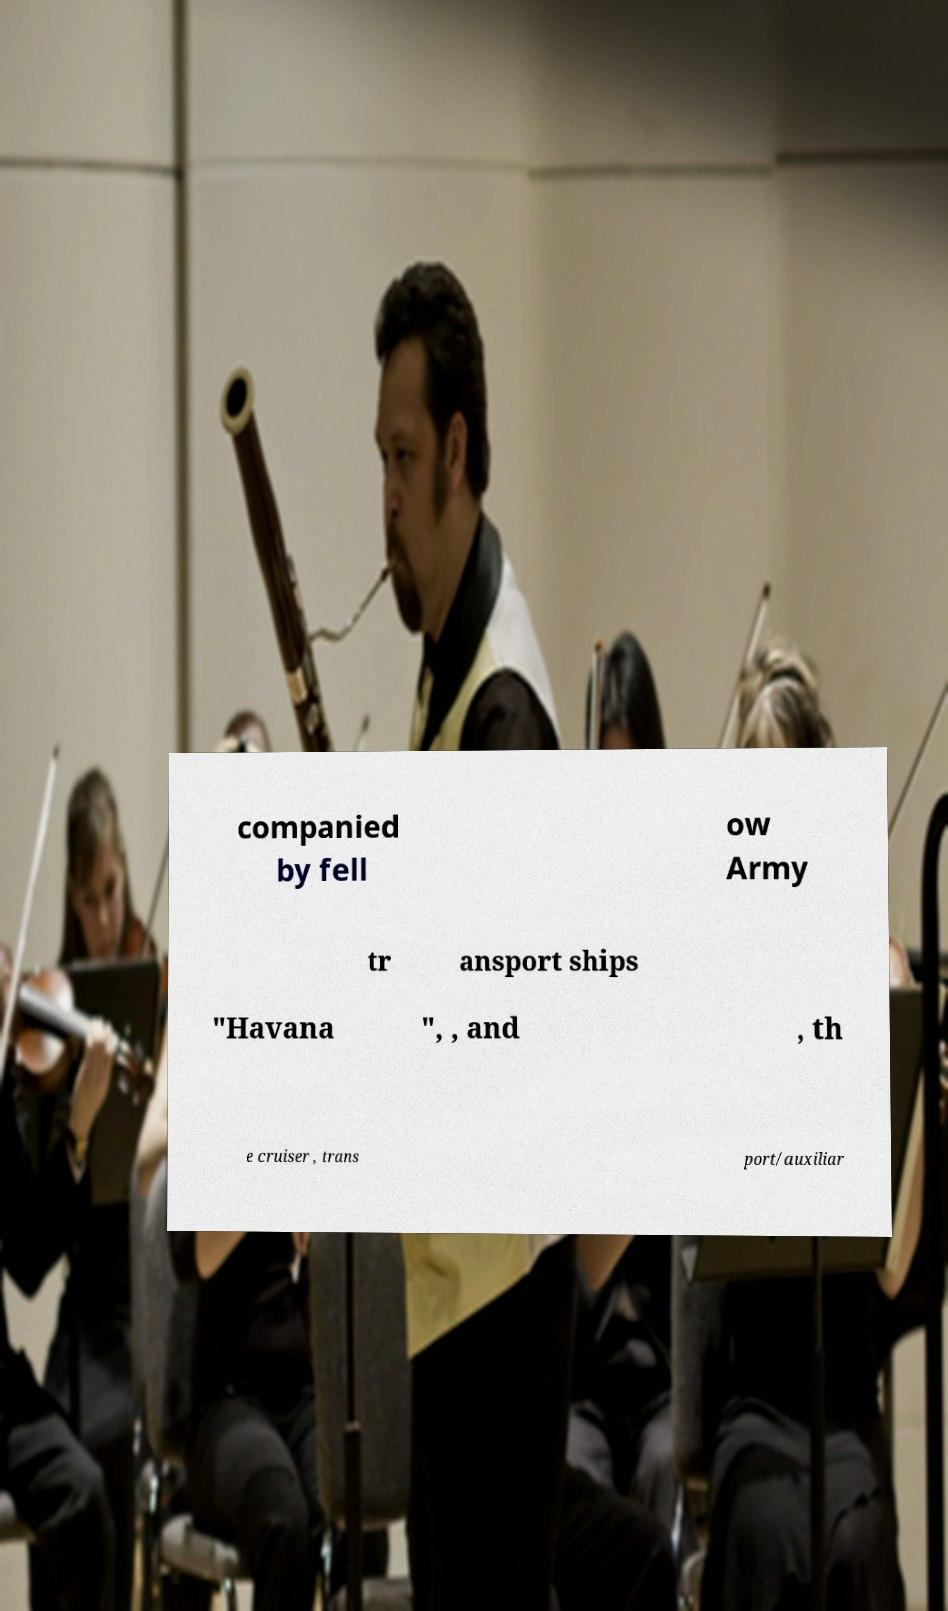For documentation purposes, I need the text within this image transcribed. Could you provide that? companied by fell ow Army tr ansport ships "Havana ", , and , th e cruiser , trans port/auxiliar 